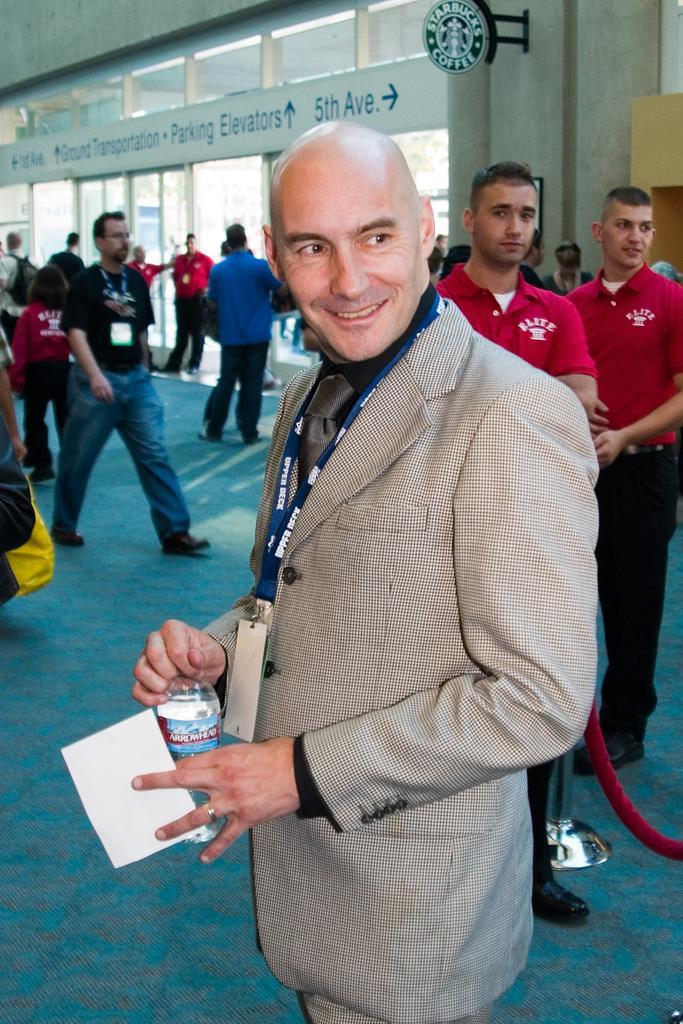Can you describe this image briefly? In this picture we can see a man wore a blazer, id card, smiling, standing, holding a paper, bottle with his hands and at the back of him we can see a group of people on the floor, name boards, wall and some objects. 